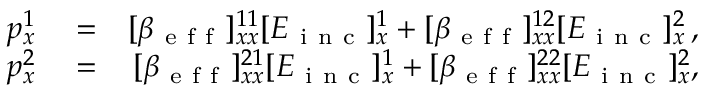Convert formula to latex. <formula><loc_0><loc_0><loc_500><loc_500>\begin{array} { r l r } { p _ { x } ^ { 1 } } & = } & { [ \beta _ { e f f } ] _ { x x } ^ { 1 1 } [ E _ { i n c } ] _ { x } ^ { 1 } + [ \beta _ { e f f } ] _ { x x } ^ { 1 2 } [ E _ { i n c } ] _ { x } ^ { 2 } \, , } \\ { p _ { x } ^ { 2 } } & = } & { [ \beta _ { e f f } ] _ { x x } ^ { 2 1 } [ E _ { i n c } ] _ { x } ^ { 1 } + [ \beta _ { e f f } ] _ { x x } ^ { 2 2 } [ E _ { i n c } ] _ { x } ^ { 2 } , } \end{array}</formula> 